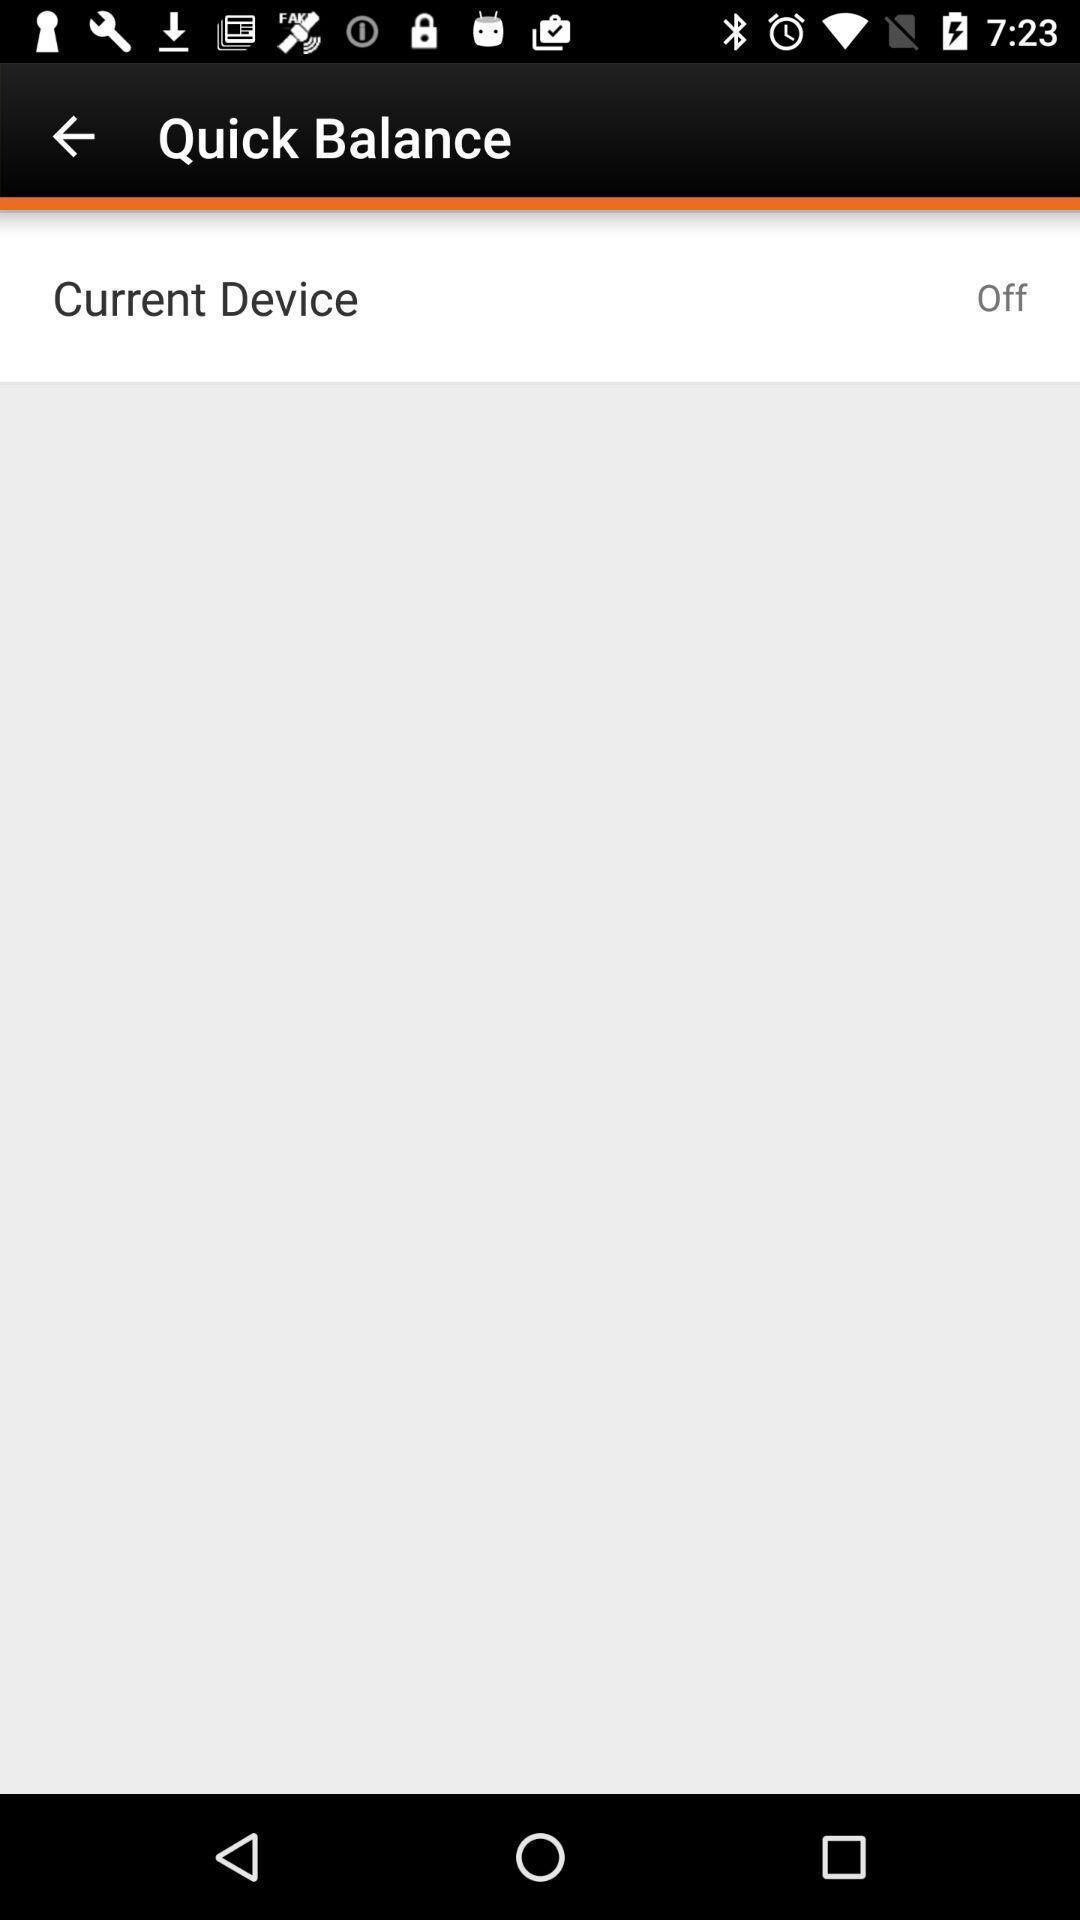Give me a summary of this screen capture. Page displaying quick balance page. 